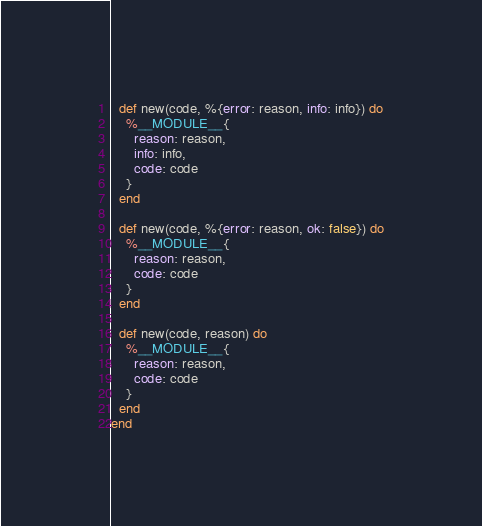<code> <loc_0><loc_0><loc_500><loc_500><_Elixir_>  def new(code, %{error: reason, info: info}) do
    %__MODULE__{
      reason: reason,
      info: info,
      code: code
    }
  end

  def new(code, %{error: reason, ok: false}) do
    %__MODULE__{
      reason: reason,
      code: code
    }
  end

  def new(code, reason) do
    %__MODULE__{
      reason: reason,
      code: code
    }
  end
end
</code> 